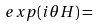Convert formula to latex. <formula><loc_0><loc_0><loc_500><loc_500>e x p ( i \theta H ) =</formula> 